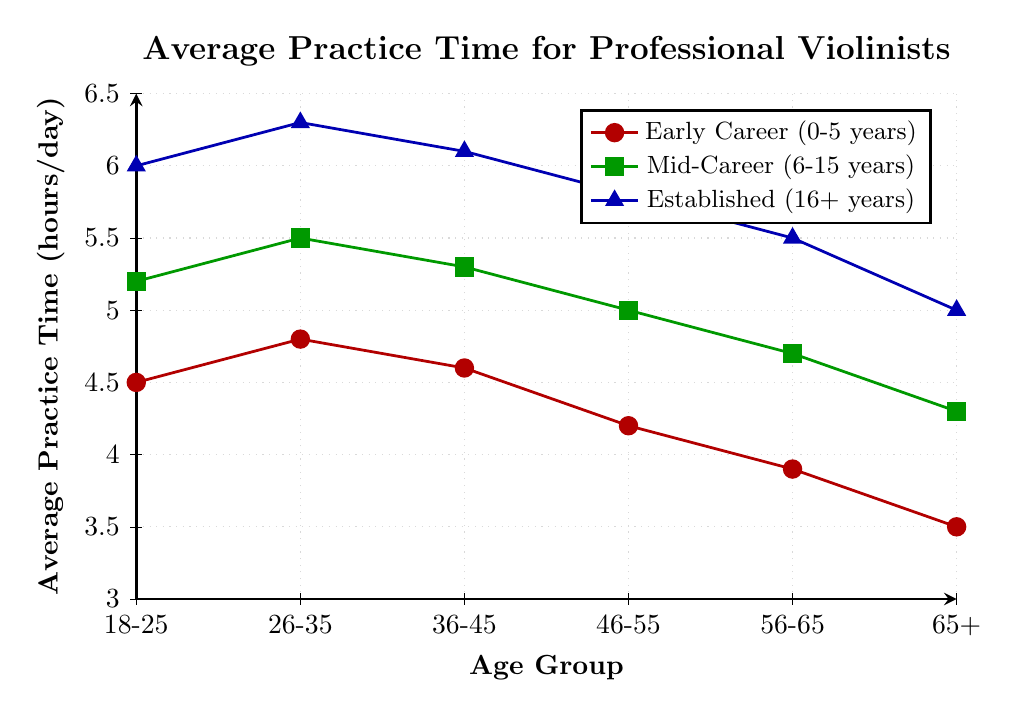What age group in the "Early Career (0-5 years)" category practices the most? By examining the red line for the "Early Career (0-5 years)" group, you can see that the highest point is at the age group 26-35 which is at 4.8 hours/day.
Answer: 26-35 How does the practice time for the "Established (16+ years)" category change from the 18-25 to the 26-35 age group? By looking at the blue line for the "Established (16+ years)" group, you'll notice it increases from 6.0 hours/day in the 18-25 age group to 6.3 hours/day in the 26-35 age group, showing an increase of 0.3 hours/day.
Answer: Increases by 0.3 hours/day Which career stage shows the steepest decline in practice hours as age increases? The steepest decline can be observed by finding the most significant downward slope. For the "Established (16+ years)" group (blue line), it drops from 6.3 hours/day in the 26-35 age group to 5.0 hours/day in the 65+ age group, covering a 1.3-hour decrease over 4 age groups, or an average of 0.325 hours per age group. The "Mid-Career (6-15 years)" group (green line) also has a steep decline but is less significant. Hence, the "Established (16+ years)" group shows the steepest decline.
Answer: Established (16+ years) What's the average practice time across all age groups for the "Mid-Career (6-15 years)" category? By summing the values for the "Mid-Career (6-15 years)" category (5.2, 5.5, 5.3, 5.0, 4.7, and 4.3) and dividing by the number of groups (6), we get (5.2 + 5.5 + 5.3 + 5.0 + 4.7 + 4.3) / 6 = 30 / 6 = 5.
Answer: 5 hours/day In which age group does the "Mid-Career (6-15 years)" group practice more than the "Established (16+ years)" group? By comparing the green line (Mid-Career) and blue line (Established), we see that the only age group where the green line is above the blue line is the 18-25 age group. In this group, Mid-Career (5.2 hours/day) practices more than Established (6.0 hours/day).
Answer: 18-25 What is the total decrease in practice hours for the "Early Career (0-5 years)" category from the age group 26-35 to the age group 65+? The practice time decreases from 4.8 hours/day in the 26-35 age group to 3.5 hours/day in the 65+ age group. The total decrease is 4.8 - 3.5 = 1.3 hours/day.
Answer: 1.3 hours/day 